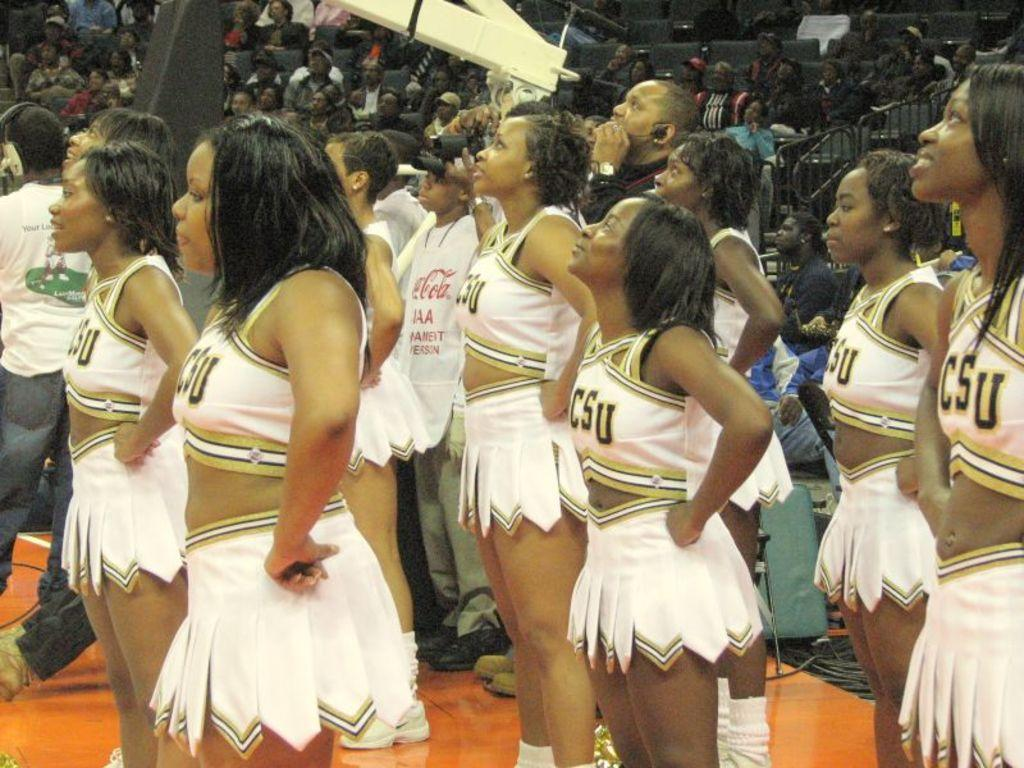<image>
Offer a succinct explanation of the picture presented. CSU cheerleaders along with a crowd of spectators are all looking up at something in the arena. 